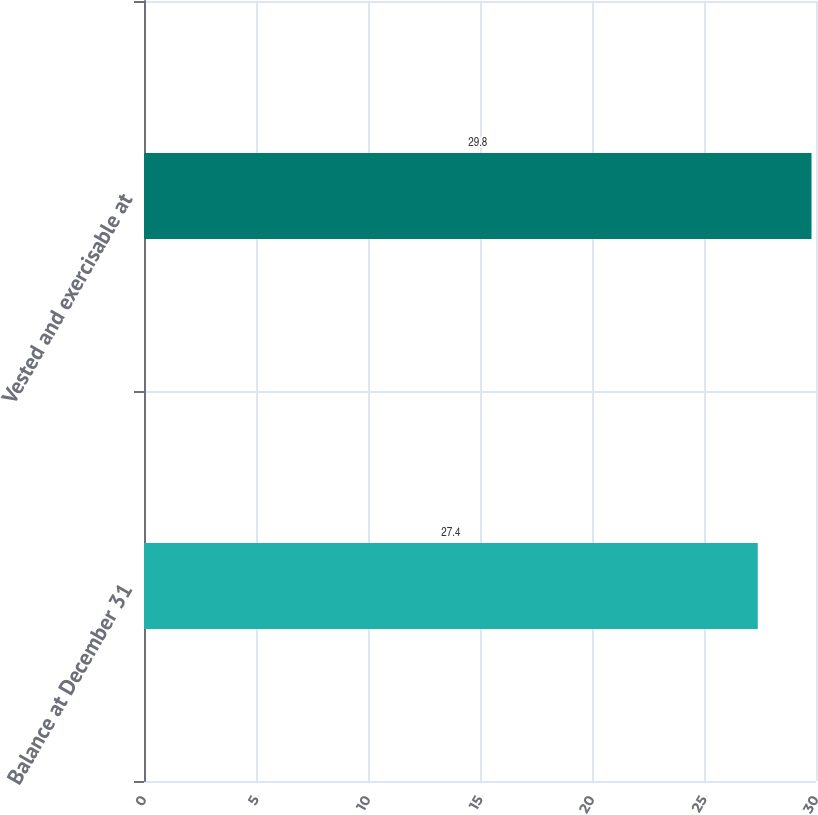Convert chart. <chart><loc_0><loc_0><loc_500><loc_500><bar_chart><fcel>Balance at December 31<fcel>Vested and exercisable at<nl><fcel>27.4<fcel>29.8<nl></chart> 